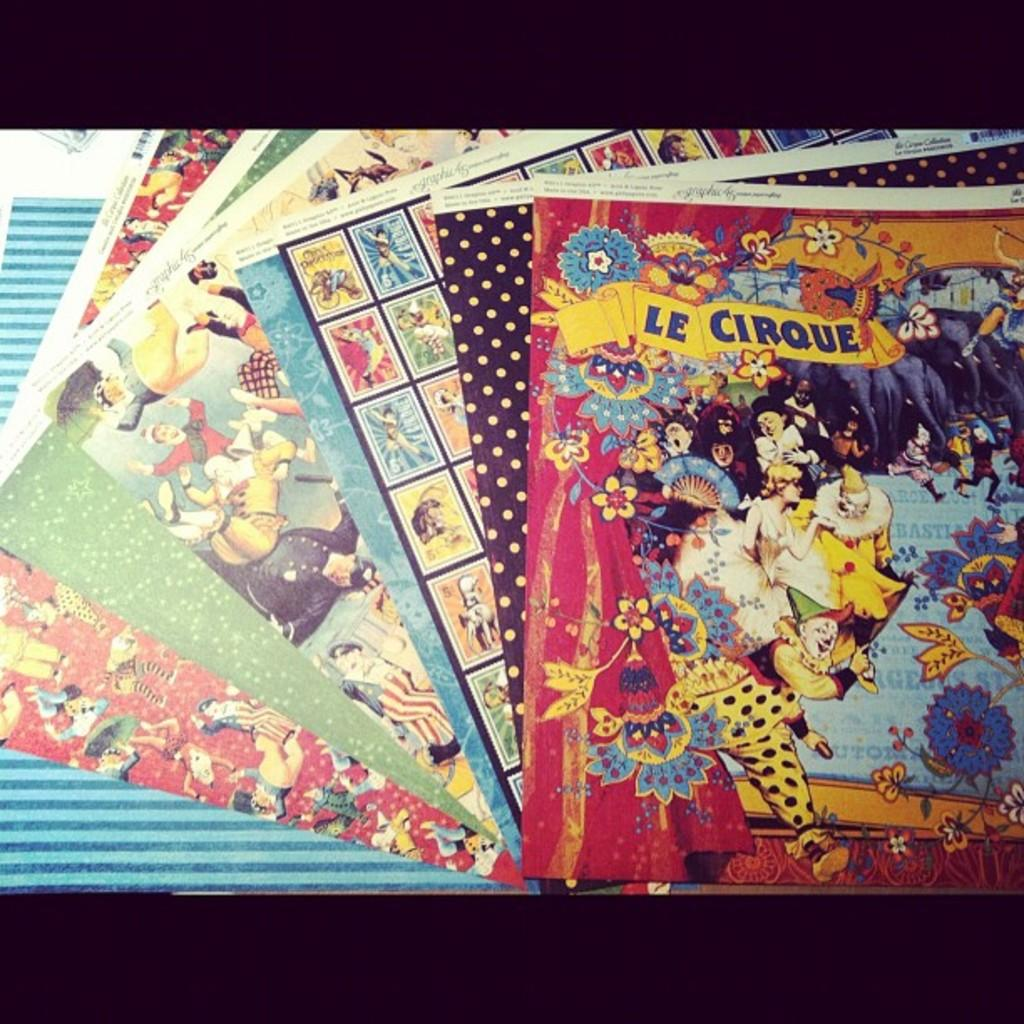<image>
Give a short and clear explanation of the subsequent image. a variety of different posters with the title "Le Cirque' on the top. 